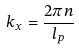Convert formula to latex. <formula><loc_0><loc_0><loc_500><loc_500>k _ { x } = \frac { 2 \pi n } { l _ { p } }</formula> 